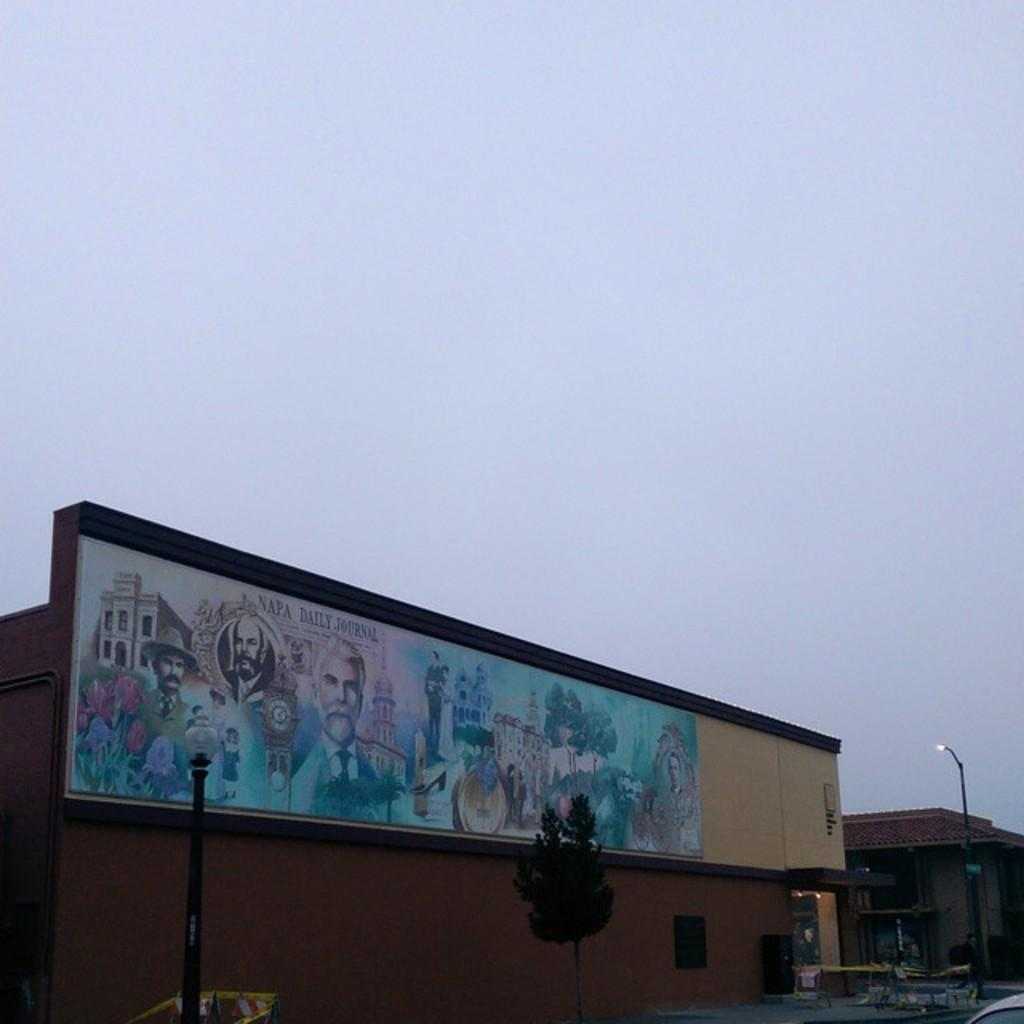<image>
Share a concise interpretation of the image provided. A graphic on the side of a building with the words Napa Daily Journal 